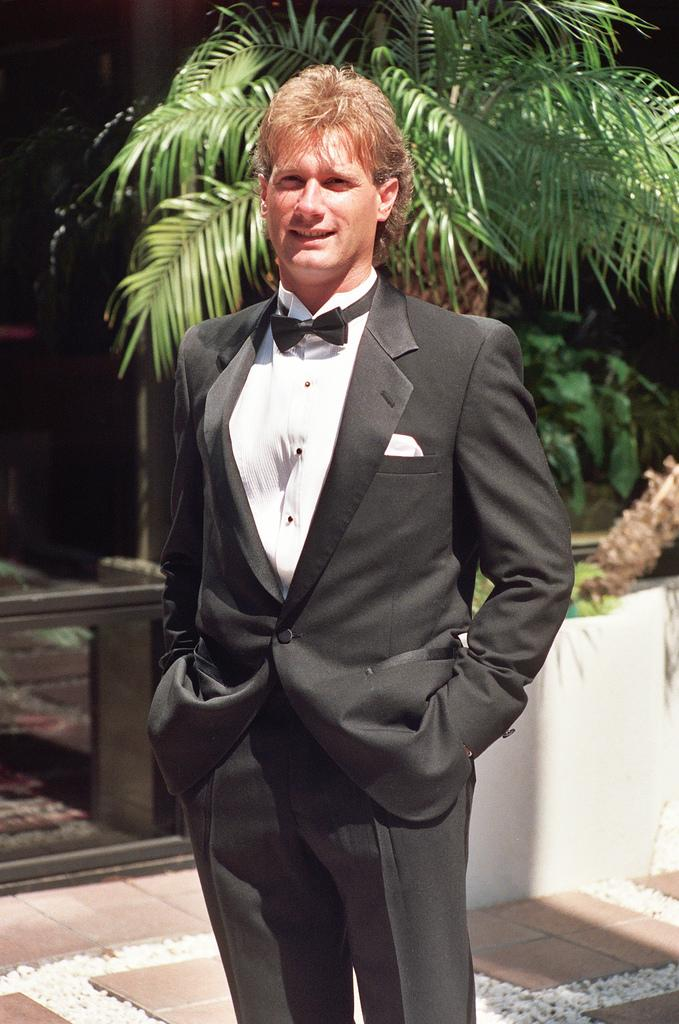What is the main subject of the image? There is a man standing in the image. What type of clothing is the man wearing? The man is wearing a blazer, a shirt, and a pant. What can be seen in the background of the image? There are plants in the background of the image. What type of zephyr can be seen blowing through the man's hair in the image? There is no zephyr present in the image, and the man's hair is not being blown by any wind. 